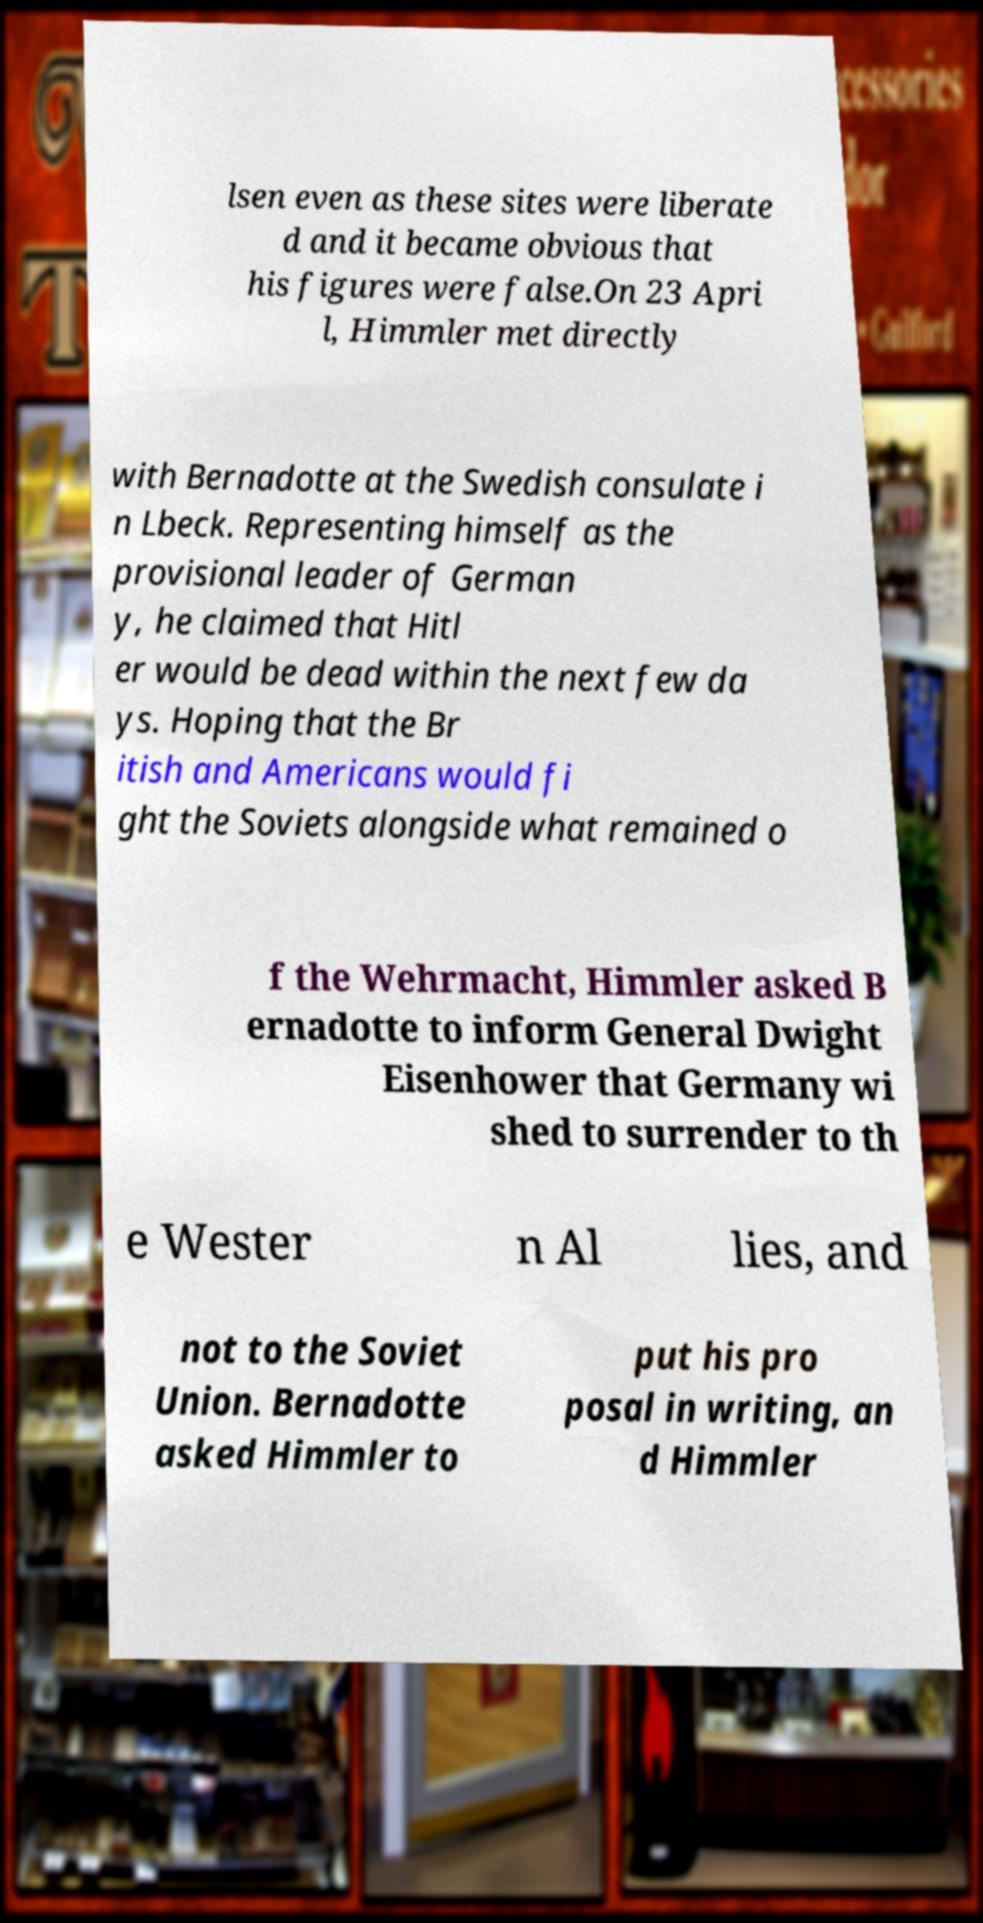Please read and relay the text visible in this image. What does it say? lsen even as these sites were liberate d and it became obvious that his figures were false.On 23 Apri l, Himmler met directly with Bernadotte at the Swedish consulate i n Lbeck. Representing himself as the provisional leader of German y, he claimed that Hitl er would be dead within the next few da ys. Hoping that the Br itish and Americans would fi ght the Soviets alongside what remained o f the Wehrmacht, Himmler asked B ernadotte to inform General Dwight Eisenhower that Germany wi shed to surrender to th e Wester n Al lies, and not to the Soviet Union. Bernadotte asked Himmler to put his pro posal in writing, an d Himmler 